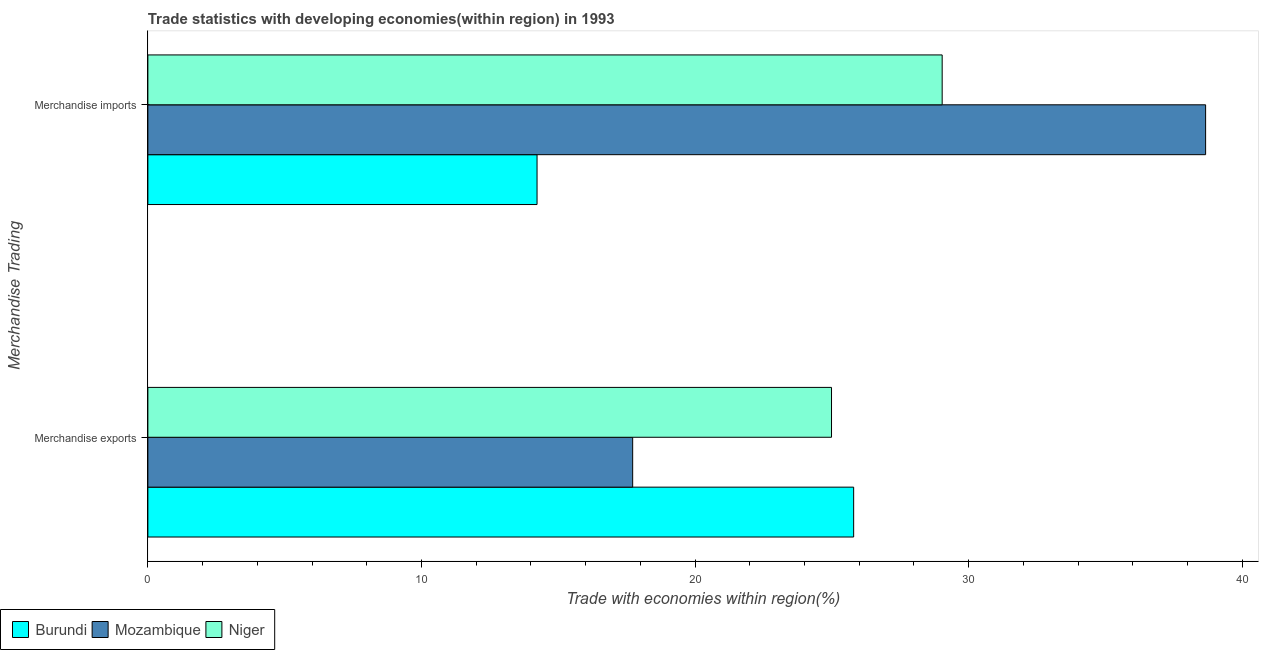How many groups of bars are there?
Make the answer very short. 2. What is the label of the 2nd group of bars from the top?
Keep it short and to the point. Merchandise exports. What is the merchandise imports in Niger?
Your response must be concise. 29.03. Across all countries, what is the maximum merchandise exports?
Make the answer very short. 25.8. Across all countries, what is the minimum merchandise imports?
Make the answer very short. 14.23. In which country was the merchandise imports maximum?
Provide a succinct answer. Mozambique. In which country was the merchandise imports minimum?
Your answer should be compact. Burundi. What is the total merchandise exports in the graph?
Offer a terse response. 68.51. What is the difference between the merchandise exports in Burundi and that in Niger?
Keep it short and to the point. 0.81. What is the difference between the merchandise exports in Mozambique and the merchandise imports in Niger?
Keep it short and to the point. -11.31. What is the average merchandise imports per country?
Offer a terse response. 27.31. What is the difference between the merchandise exports and merchandise imports in Niger?
Your answer should be compact. -4.04. In how many countries, is the merchandise exports greater than 4 %?
Offer a terse response. 3. What is the ratio of the merchandise imports in Niger to that in Burundi?
Provide a succinct answer. 2.04. What does the 3rd bar from the top in Merchandise imports represents?
Provide a short and direct response. Burundi. What does the 1st bar from the bottom in Merchandise exports represents?
Your answer should be very brief. Burundi. How many bars are there?
Provide a succinct answer. 6. What is the difference between two consecutive major ticks on the X-axis?
Offer a very short reply. 10. Where does the legend appear in the graph?
Make the answer very short. Bottom left. What is the title of the graph?
Provide a succinct answer. Trade statistics with developing economies(within region) in 1993. Does "Sint Maarten (Dutch part)" appear as one of the legend labels in the graph?
Provide a short and direct response. No. What is the label or title of the X-axis?
Ensure brevity in your answer.  Trade with economies within region(%). What is the label or title of the Y-axis?
Provide a short and direct response. Merchandise Trading. What is the Trade with economies within region(%) in Burundi in Merchandise exports?
Ensure brevity in your answer.  25.8. What is the Trade with economies within region(%) of Mozambique in Merchandise exports?
Provide a short and direct response. 17.72. What is the Trade with economies within region(%) in Niger in Merchandise exports?
Give a very brief answer. 24.99. What is the Trade with economies within region(%) of Burundi in Merchandise imports?
Provide a short and direct response. 14.23. What is the Trade with economies within region(%) in Mozambique in Merchandise imports?
Offer a very short reply. 38.66. What is the Trade with economies within region(%) in Niger in Merchandise imports?
Offer a terse response. 29.03. Across all Merchandise Trading, what is the maximum Trade with economies within region(%) of Burundi?
Keep it short and to the point. 25.8. Across all Merchandise Trading, what is the maximum Trade with economies within region(%) in Mozambique?
Give a very brief answer. 38.66. Across all Merchandise Trading, what is the maximum Trade with economies within region(%) in Niger?
Offer a terse response. 29.03. Across all Merchandise Trading, what is the minimum Trade with economies within region(%) of Burundi?
Give a very brief answer. 14.23. Across all Merchandise Trading, what is the minimum Trade with economies within region(%) of Mozambique?
Your answer should be compact. 17.72. Across all Merchandise Trading, what is the minimum Trade with economies within region(%) of Niger?
Provide a succinct answer. 24.99. What is the total Trade with economies within region(%) in Burundi in the graph?
Your answer should be very brief. 40.02. What is the total Trade with economies within region(%) in Mozambique in the graph?
Your answer should be compact. 56.38. What is the total Trade with economies within region(%) in Niger in the graph?
Provide a succinct answer. 54.02. What is the difference between the Trade with economies within region(%) in Burundi in Merchandise exports and that in Merchandise imports?
Provide a succinct answer. 11.57. What is the difference between the Trade with economies within region(%) of Mozambique in Merchandise exports and that in Merchandise imports?
Your answer should be compact. -20.94. What is the difference between the Trade with economies within region(%) of Niger in Merchandise exports and that in Merchandise imports?
Offer a terse response. -4.04. What is the difference between the Trade with economies within region(%) in Burundi in Merchandise exports and the Trade with economies within region(%) in Mozambique in Merchandise imports?
Provide a short and direct response. -12.86. What is the difference between the Trade with economies within region(%) in Burundi in Merchandise exports and the Trade with economies within region(%) in Niger in Merchandise imports?
Make the answer very short. -3.24. What is the difference between the Trade with economies within region(%) in Mozambique in Merchandise exports and the Trade with economies within region(%) in Niger in Merchandise imports?
Your response must be concise. -11.31. What is the average Trade with economies within region(%) of Burundi per Merchandise Trading?
Make the answer very short. 20.01. What is the average Trade with economies within region(%) of Mozambique per Merchandise Trading?
Keep it short and to the point. 28.19. What is the average Trade with economies within region(%) in Niger per Merchandise Trading?
Offer a very short reply. 27.01. What is the difference between the Trade with economies within region(%) in Burundi and Trade with economies within region(%) in Mozambique in Merchandise exports?
Your response must be concise. 8.08. What is the difference between the Trade with economies within region(%) of Burundi and Trade with economies within region(%) of Niger in Merchandise exports?
Your answer should be very brief. 0.81. What is the difference between the Trade with economies within region(%) of Mozambique and Trade with economies within region(%) of Niger in Merchandise exports?
Your response must be concise. -7.27. What is the difference between the Trade with economies within region(%) of Burundi and Trade with economies within region(%) of Mozambique in Merchandise imports?
Ensure brevity in your answer.  -24.44. What is the difference between the Trade with economies within region(%) in Burundi and Trade with economies within region(%) in Niger in Merchandise imports?
Offer a very short reply. -14.81. What is the difference between the Trade with economies within region(%) in Mozambique and Trade with economies within region(%) in Niger in Merchandise imports?
Keep it short and to the point. 9.63. What is the ratio of the Trade with economies within region(%) in Burundi in Merchandise exports to that in Merchandise imports?
Offer a very short reply. 1.81. What is the ratio of the Trade with economies within region(%) in Mozambique in Merchandise exports to that in Merchandise imports?
Give a very brief answer. 0.46. What is the ratio of the Trade with economies within region(%) of Niger in Merchandise exports to that in Merchandise imports?
Give a very brief answer. 0.86. What is the difference between the highest and the second highest Trade with economies within region(%) in Burundi?
Your response must be concise. 11.57. What is the difference between the highest and the second highest Trade with economies within region(%) of Mozambique?
Keep it short and to the point. 20.94. What is the difference between the highest and the second highest Trade with economies within region(%) of Niger?
Your answer should be very brief. 4.04. What is the difference between the highest and the lowest Trade with economies within region(%) of Burundi?
Provide a succinct answer. 11.57. What is the difference between the highest and the lowest Trade with economies within region(%) of Mozambique?
Ensure brevity in your answer.  20.94. What is the difference between the highest and the lowest Trade with economies within region(%) of Niger?
Offer a terse response. 4.04. 